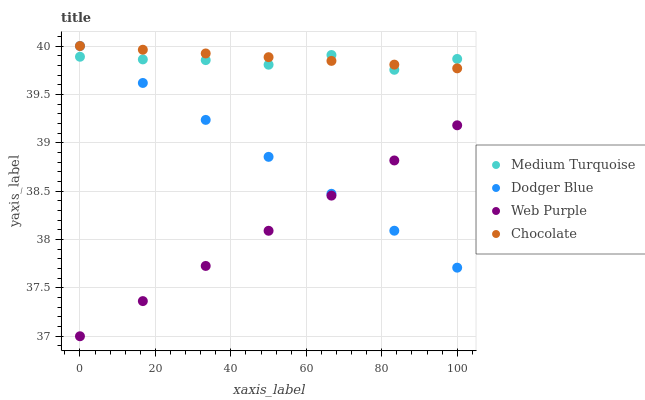Does Web Purple have the minimum area under the curve?
Answer yes or no. Yes. Does Chocolate have the maximum area under the curve?
Answer yes or no. Yes. Does Dodger Blue have the minimum area under the curve?
Answer yes or no. No. Does Dodger Blue have the maximum area under the curve?
Answer yes or no. No. Is Chocolate the smoothest?
Answer yes or no. Yes. Is Medium Turquoise the roughest?
Answer yes or no. Yes. Is Dodger Blue the smoothest?
Answer yes or no. No. Is Dodger Blue the roughest?
Answer yes or no. No. Does Web Purple have the lowest value?
Answer yes or no. Yes. Does Dodger Blue have the lowest value?
Answer yes or no. No. Does Chocolate have the highest value?
Answer yes or no. Yes. Does Medium Turquoise have the highest value?
Answer yes or no. No. Is Web Purple less than Chocolate?
Answer yes or no. Yes. Is Medium Turquoise greater than Web Purple?
Answer yes or no. Yes. Does Chocolate intersect Dodger Blue?
Answer yes or no. Yes. Is Chocolate less than Dodger Blue?
Answer yes or no. No. Is Chocolate greater than Dodger Blue?
Answer yes or no. No. Does Web Purple intersect Chocolate?
Answer yes or no. No. 